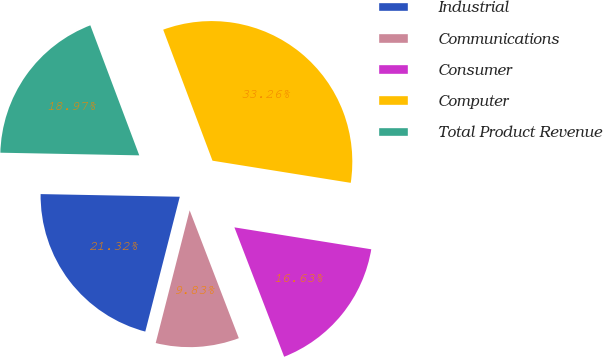Convert chart. <chart><loc_0><loc_0><loc_500><loc_500><pie_chart><fcel>Industrial<fcel>Communications<fcel>Consumer<fcel>Computer<fcel>Total Product Revenue<nl><fcel>21.32%<fcel>9.83%<fcel>16.63%<fcel>33.26%<fcel>18.97%<nl></chart> 